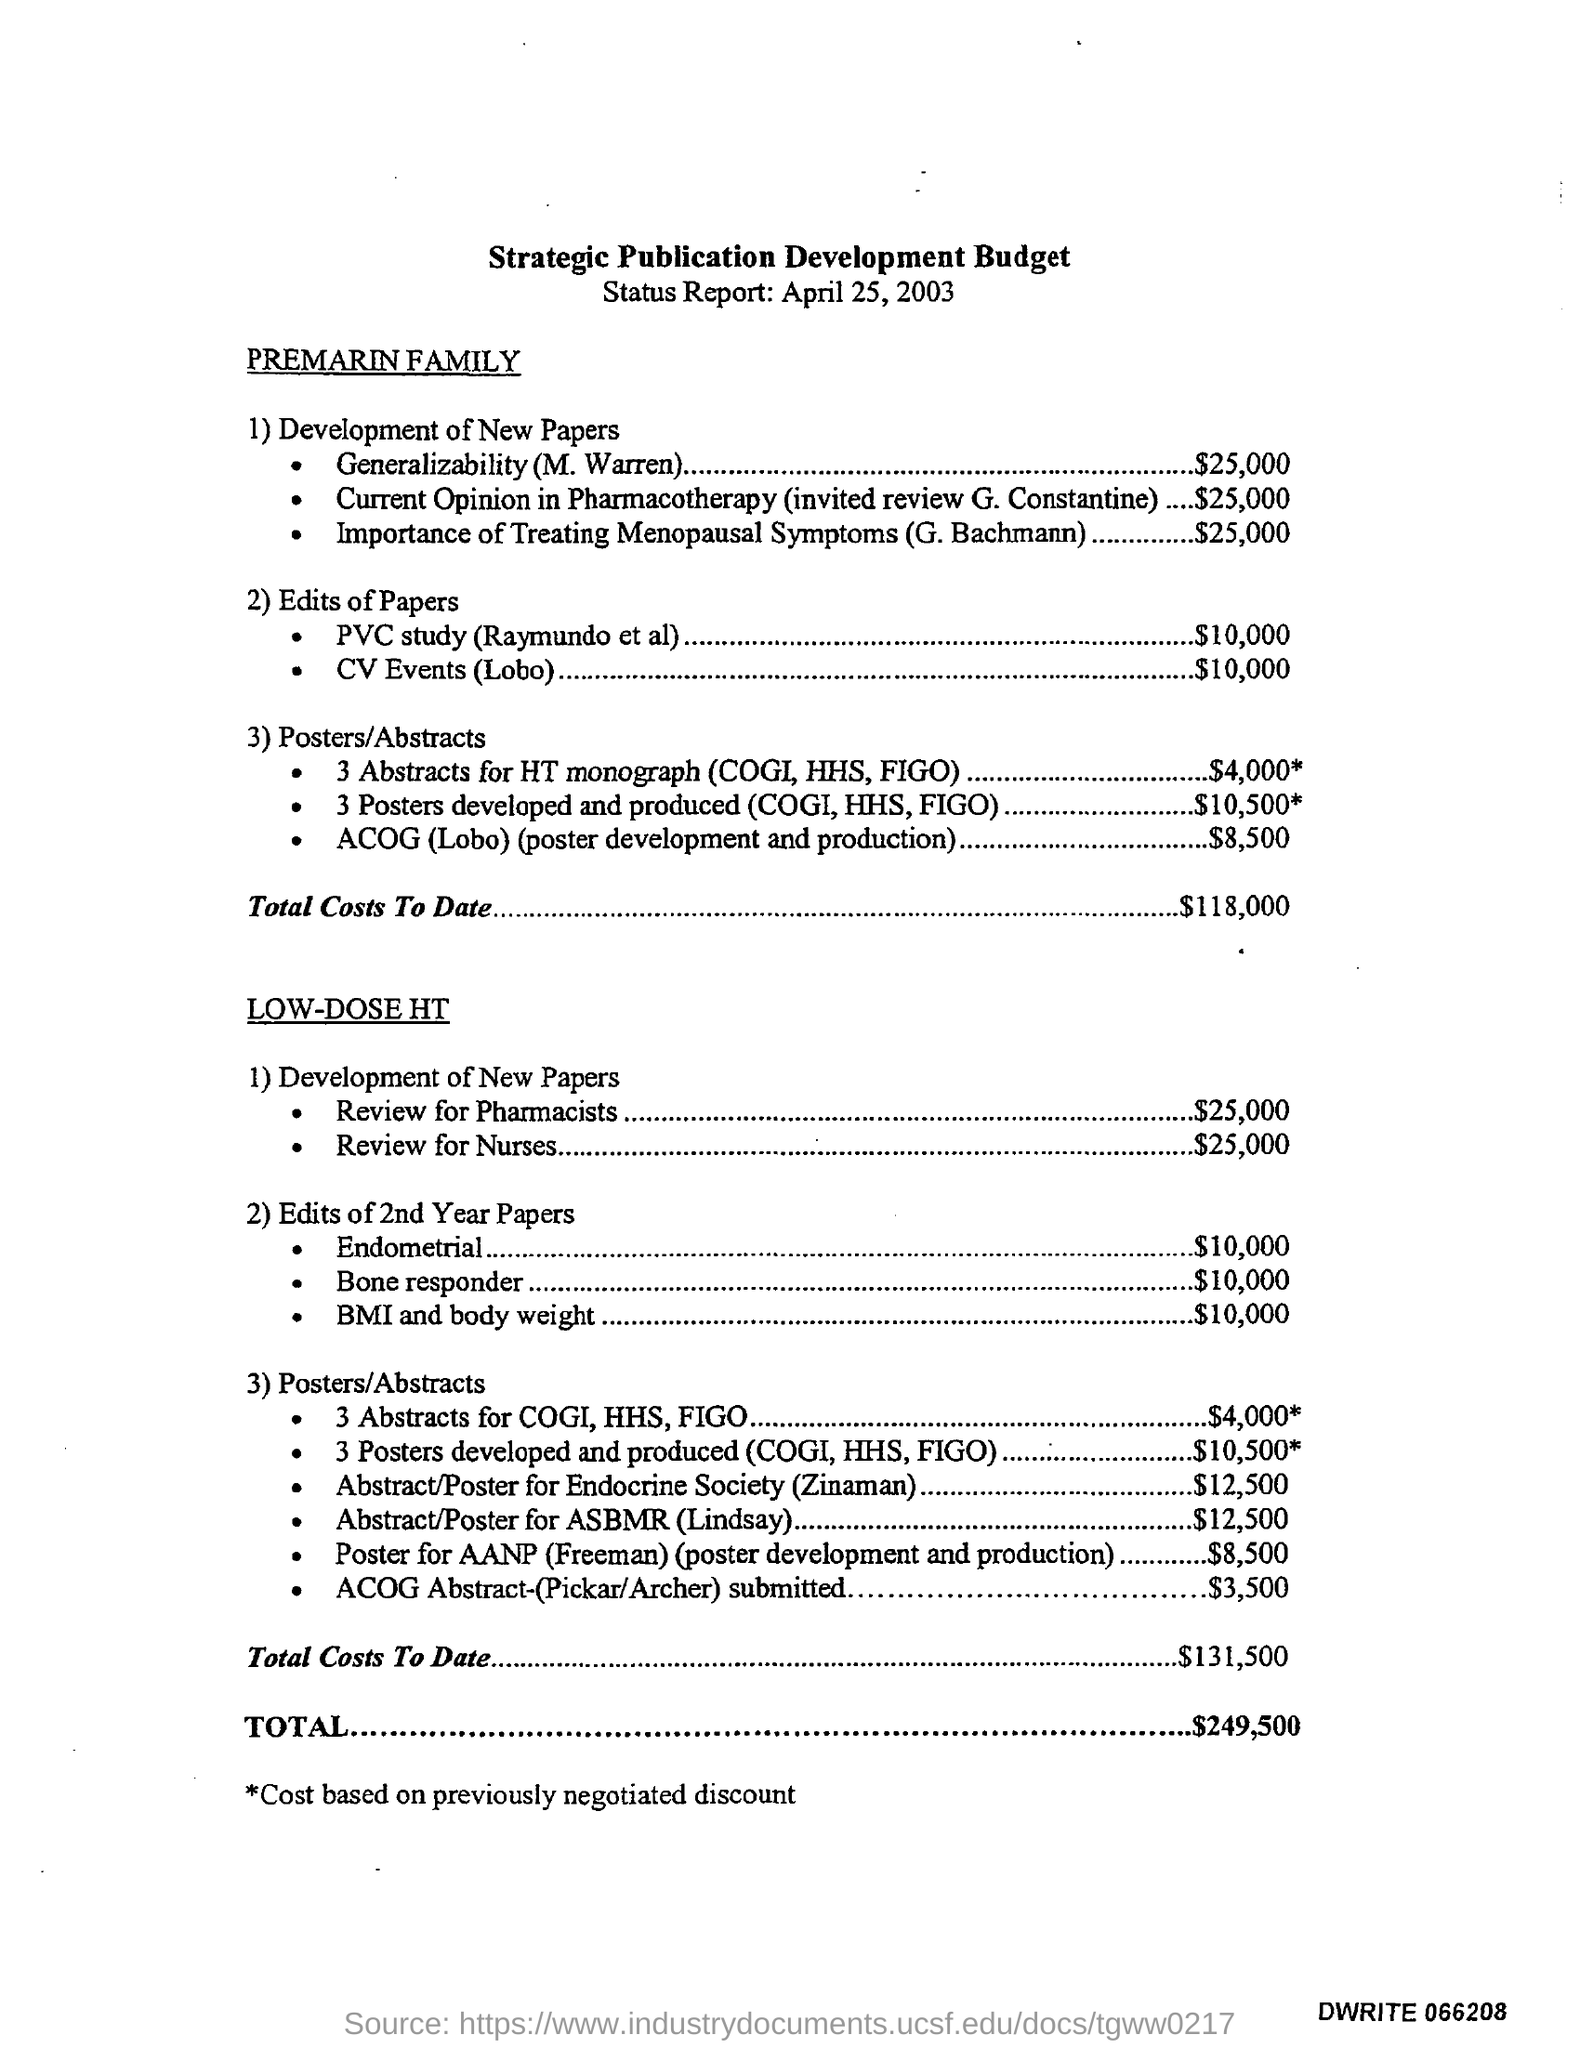Mention a couple of crucial points in this snapshot. The total budget mentioned in the given report is $249,500. The budget for the PVC study in the edits of papers is $10,000. The budget for CV events (Lobo) in the edits of papers is $10,000. 